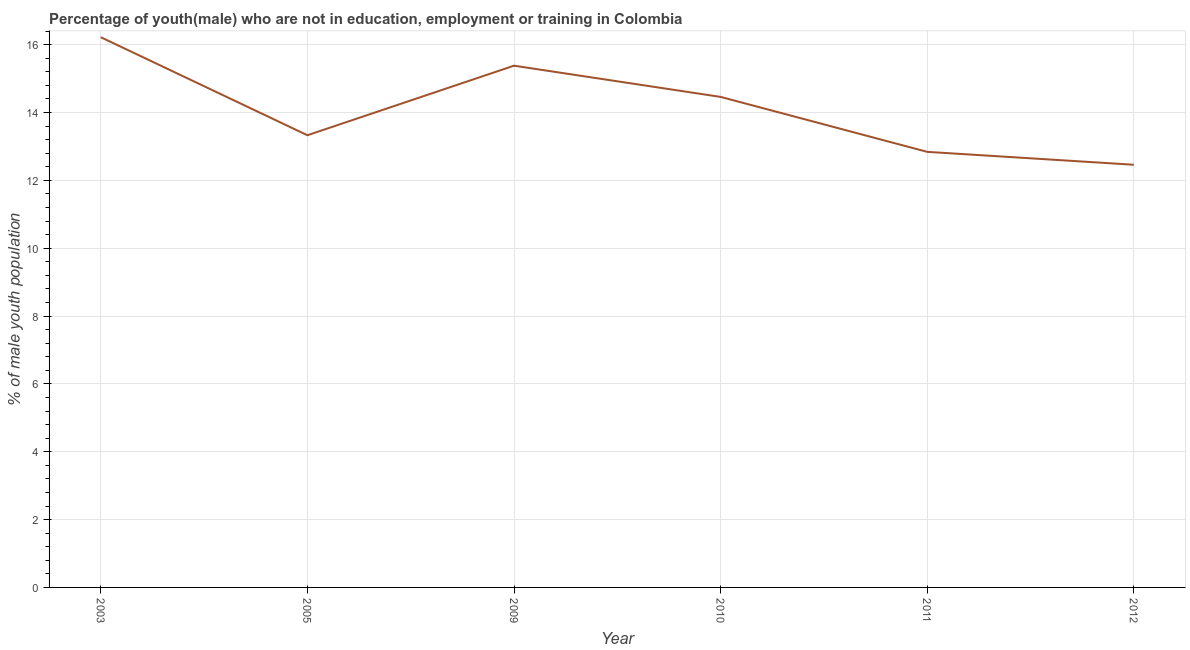What is the unemployed male youth population in 2009?
Make the answer very short. 15.38. Across all years, what is the maximum unemployed male youth population?
Your answer should be compact. 16.22. Across all years, what is the minimum unemployed male youth population?
Make the answer very short. 12.46. In which year was the unemployed male youth population maximum?
Give a very brief answer. 2003. What is the sum of the unemployed male youth population?
Ensure brevity in your answer.  84.69. What is the difference between the unemployed male youth population in 2003 and 2011?
Your response must be concise. 3.38. What is the average unemployed male youth population per year?
Offer a very short reply. 14.11. What is the median unemployed male youth population?
Give a very brief answer. 13.89. In how many years, is the unemployed male youth population greater than 1.2000000000000002 %?
Give a very brief answer. 6. Do a majority of the years between 2011 and 2003 (inclusive) have unemployed male youth population greater than 14.8 %?
Your answer should be very brief. Yes. What is the ratio of the unemployed male youth population in 2011 to that in 2012?
Offer a very short reply. 1.03. Is the unemployed male youth population in 2009 less than that in 2012?
Your answer should be very brief. No. Is the difference between the unemployed male youth population in 2003 and 2010 greater than the difference between any two years?
Your response must be concise. No. What is the difference between the highest and the second highest unemployed male youth population?
Your answer should be very brief. 0.84. What is the difference between the highest and the lowest unemployed male youth population?
Provide a short and direct response. 3.76. In how many years, is the unemployed male youth population greater than the average unemployed male youth population taken over all years?
Provide a short and direct response. 3. Does the unemployed male youth population monotonically increase over the years?
Your answer should be very brief. No. Are the values on the major ticks of Y-axis written in scientific E-notation?
Your response must be concise. No. Does the graph contain grids?
Keep it short and to the point. Yes. What is the title of the graph?
Provide a short and direct response. Percentage of youth(male) who are not in education, employment or training in Colombia. What is the label or title of the Y-axis?
Offer a terse response. % of male youth population. What is the % of male youth population of 2003?
Offer a very short reply. 16.22. What is the % of male youth population in 2005?
Your answer should be compact. 13.33. What is the % of male youth population in 2009?
Your response must be concise. 15.38. What is the % of male youth population of 2010?
Your answer should be compact. 14.46. What is the % of male youth population of 2011?
Offer a terse response. 12.84. What is the % of male youth population of 2012?
Your answer should be compact. 12.46. What is the difference between the % of male youth population in 2003 and 2005?
Offer a very short reply. 2.89. What is the difference between the % of male youth population in 2003 and 2009?
Provide a succinct answer. 0.84. What is the difference between the % of male youth population in 2003 and 2010?
Your response must be concise. 1.76. What is the difference between the % of male youth population in 2003 and 2011?
Provide a short and direct response. 3.38. What is the difference between the % of male youth population in 2003 and 2012?
Ensure brevity in your answer.  3.76. What is the difference between the % of male youth population in 2005 and 2009?
Provide a short and direct response. -2.05. What is the difference between the % of male youth population in 2005 and 2010?
Your response must be concise. -1.13. What is the difference between the % of male youth population in 2005 and 2011?
Give a very brief answer. 0.49. What is the difference between the % of male youth population in 2005 and 2012?
Provide a succinct answer. 0.87. What is the difference between the % of male youth population in 2009 and 2011?
Give a very brief answer. 2.54. What is the difference between the % of male youth population in 2009 and 2012?
Give a very brief answer. 2.92. What is the difference between the % of male youth population in 2010 and 2011?
Give a very brief answer. 1.62. What is the difference between the % of male youth population in 2011 and 2012?
Offer a terse response. 0.38. What is the ratio of the % of male youth population in 2003 to that in 2005?
Ensure brevity in your answer.  1.22. What is the ratio of the % of male youth population in 2003 to that in 2009?
Provide a short and direct response. 1.05. What is the ratio of the % of male youth population in 2003 to that in 2010?
Your answer should be compact. 1.12. What is the ratio of the % of male youth population in 2003 to that in 2011?
Provide a short and direct response. 1.26. What is the ratio of the % of male youth population in 2003 to that in 2012?
Ensure brevity in your answer.  1.3. What is the ratio of the % of male youth population in 2005 to that in 2009?
Your response must be concise. 0.87. What is the ratio of the % of male youth population in 2005 to that in 2010?
Offer a terse response. 0.92. What is the ratio of the % of male youth population in 2005 to that in 2011?
Your answer should be very brief. 1.04. What is the ratio of the % of male youth population in 2005 to that in 2012?
Your response must be concise. 1.07. What is the ratio of the % of male youth population in 2009 to that in 2010?
Offer a terse response. 1.06. What is the ratio of the % of male youth population in 2009 to that in 2011?
Make the answer very short. 1.2. What is the ratio of the % of male youth population in 2009 to that in 2012?
Your answer should be compact. 1.23. What is the ratio of the % of male youth population in 2010 to that in 2011?
Your answer should be compact. 1.13. What is the ratio of the % of male youth population in 2010 to that in 2012?
Make the answer very short. 1.16. 